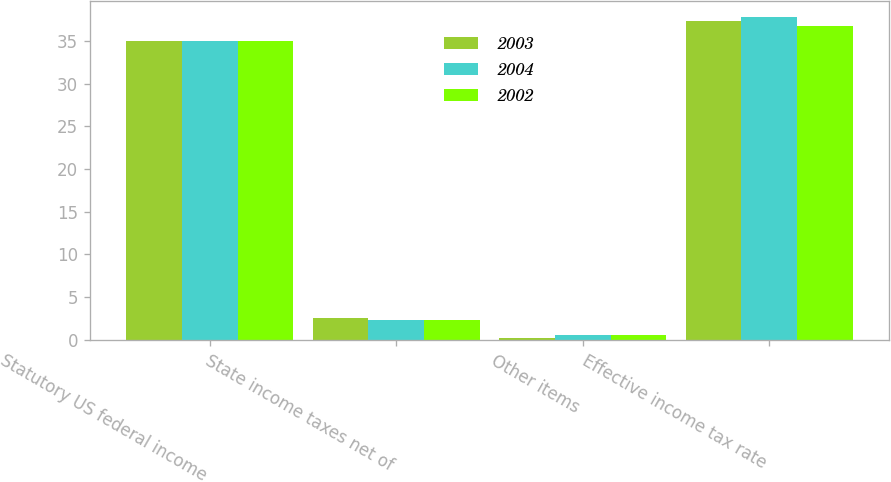Convert chart to OTSL. <chart><loc_0><loc_0><loc_500><loc_500><stacked_bar_chart><ecel><fcel>Statutory US federal income<fcel>State income taxes net of<fcel>Other items<fcel>Effective income tax rate<nl><fcel>2003<fcel>35<fcel>2.5<fcel>0.2<fcel>37.3<nl><fcel>2004<fcel>35<fcel>2.3<fcel>0.5<fcel>37.8<nl><fcel>2002<fcel>35<fcel>2.3<fcel>0.5<fcel>36.8<nl></chart> 